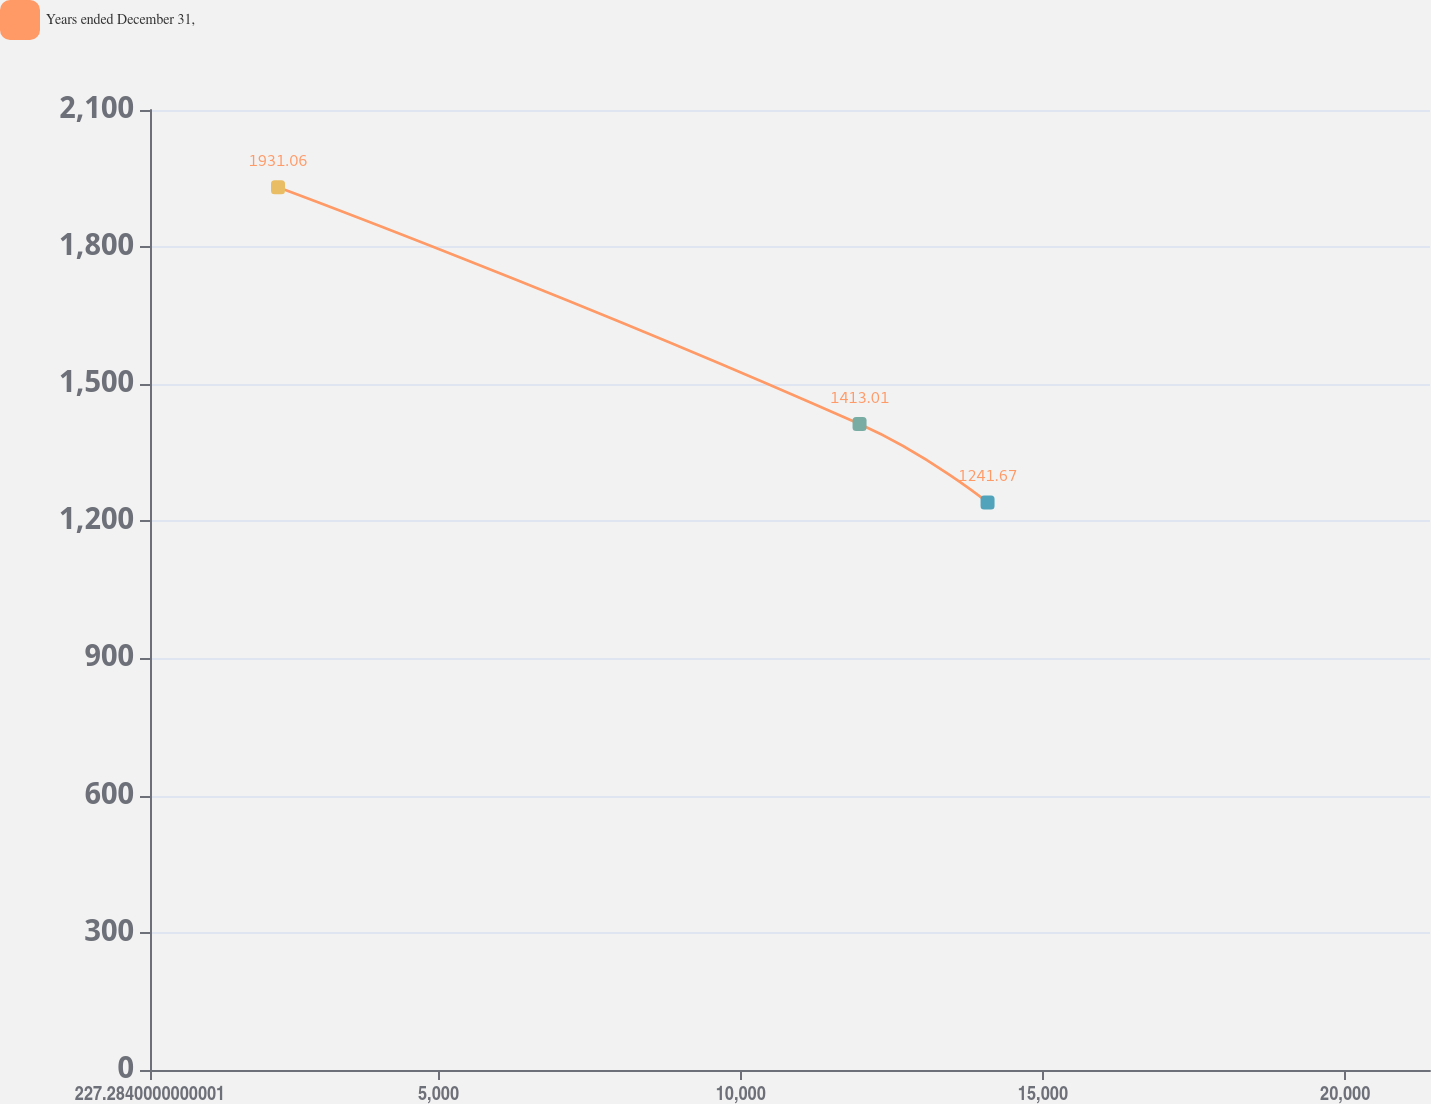Convert chart. <chart><loc_0><loc_0><loc_500><loc_500><line_chart><ecel><fcel>Years ended December 31,<nl><fcel>2344.9<fcel>1931.06<nl><fcel>11966<fcel>1413.01<nl><fcel>14083.6<fcel>1241.67<nl><fcel>23521.1<fcel>2515.82<nl></chart> 